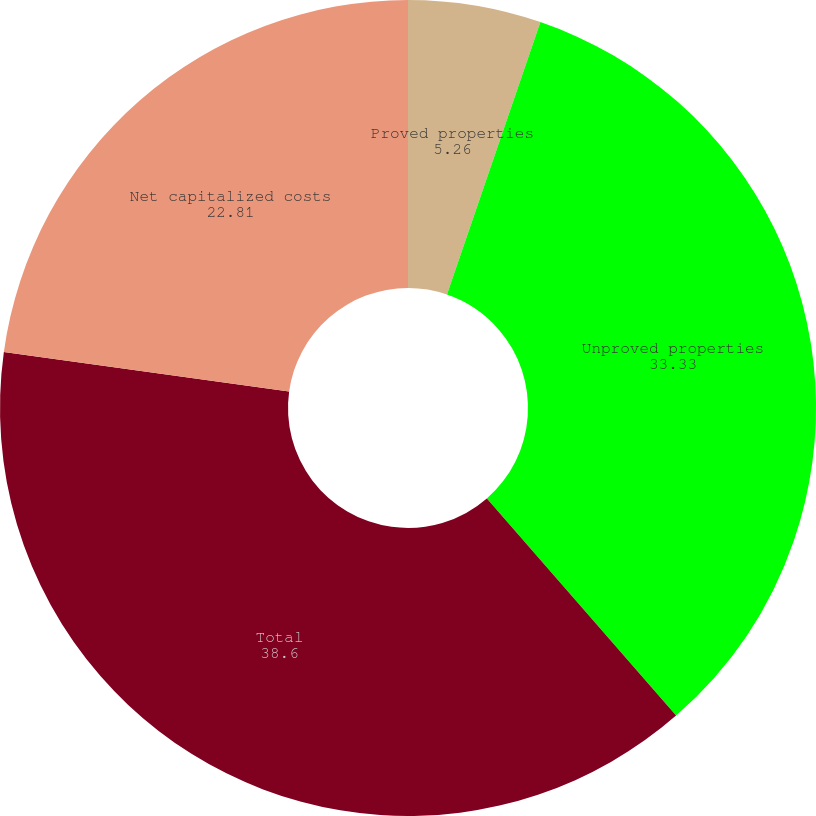Convert chart. <chart><loc_0><loc_0><loc_500><loc_500><pie_chart><fcel>Proved properties<fcel>Unproved properties<fcel>Total<fcel>Net capitalized costs<nl><fcel>5.26%<fcel>33.33%<fcel>38.6%<fcel>22.81%<nl></chart> 